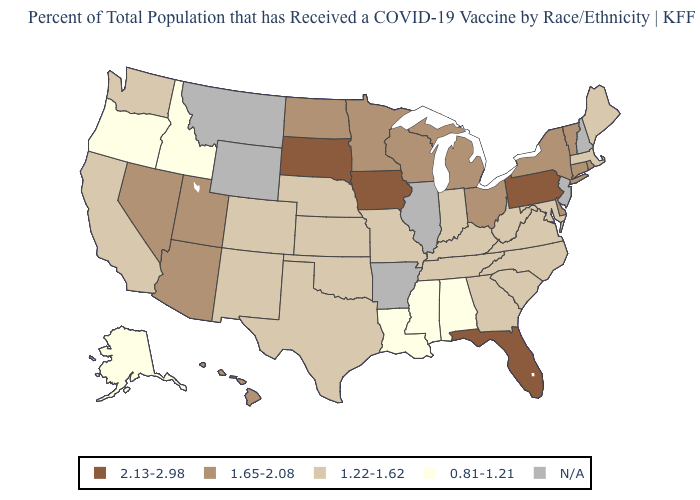What is the highest value in the Northeast ?
Answer briefly. 2.13-2.98. Is the legend a continuous bar?
Concise answer only. No. What is the value of Delaware?
Write a very short answer. 1.65-2.08. Name the states that have a value in the range 1.65-2.08?
Answer briefly. Arizona, Connecticut, Delaware, Hawaii, Michigan, Minnesota, Nevada, New York, North Dakota, Ohio, Rhode Island, Utah, Vermont, Wisconsin. Does the map have missing data?
Quick response, please. Yes. What is the value of Louisiana?
Short answer required. 0.81-1.21. What is the value of Utah?
Short answer required. 1.65-2.08. What is the value of Montana?
Be succinct. N/A. What is the value of Louisiana?
Be succinct. 0.81-1.21. Which states have the lowest value in the USA?
Concise answer only. Alabama, Alaska, Idaho, Louisiana, Mississippi, Oregon. What is the value of Kansas?
Keep it brief. 1.22-1.62. What is the value of Oregon?
Quick response, please. 0.81-1.21. What is the value of Michigan?
Write a very short answer. 1.65-2.08. Among the states that border Rhode Island , which have the highest value?
Short answer required. Connecticut. 